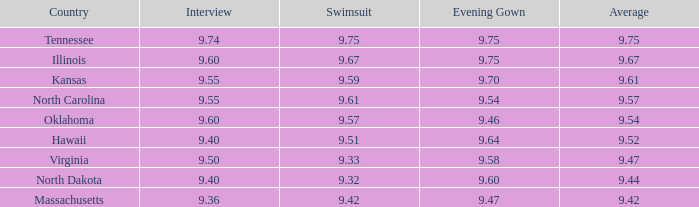What was the evening gown score when the swimsuit was 9.61? 9.54. 